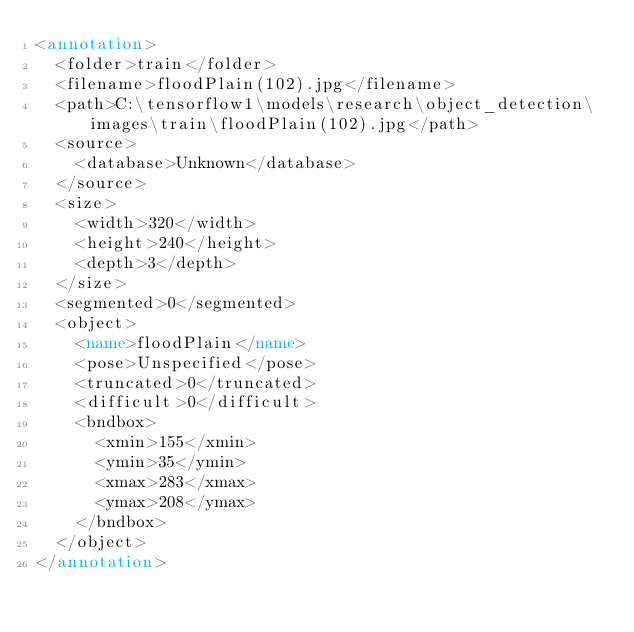<code> <loc_0><loc_0><loc_500><loc_500><_XML_><annotation>
	<folder>train</folder>
	<filename>floodPlain(102).jpg</filename>
	<path>C:\tensorflow1\models\research\object_detection\images\train\floodPlain(102).jpg</path>
	<source>
		<database>Unknown</database>
	</source>
	<size>
		<width>320</width>
		<height>240</height>
		<depth>3</depth>
	</size>
	<segmented>0</segmented>
	<object>
		<name>floodPlain</name>
		<pose>Unspecified</pose>
		<truncated>0</truncated>
		<difficult>0</difficult>
		<bndbox>
			<xmin>155</xmin>
			<ymin>35</ymin>
			<xmax>283</xmax>
			<ymax>208</ymax>
		</bndbox>
	</object>
</annotation>
</code> 